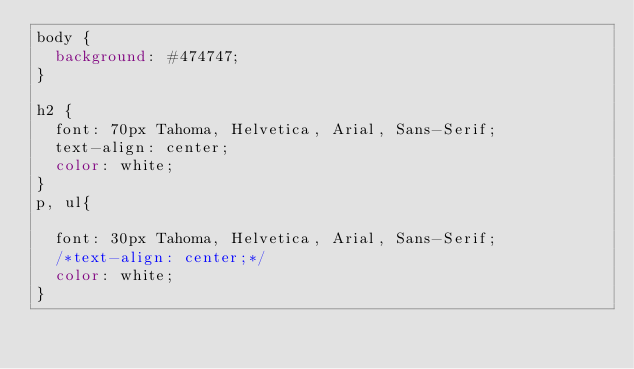<code> <loc_0><loc_0><loc_500><loc_500><_CSS_>body {
	background: #474747;
}

h2 {
	font: 70px Tahoma, Helvetica, Arial, Sans-Serif;
	text-align: center;
	color: white;
}
p, ul{

	font: 30px Tahoma, Helvetica, Arial, Sans-Serif;
	/*text-align: center;*/
	color: white;
}</code> 